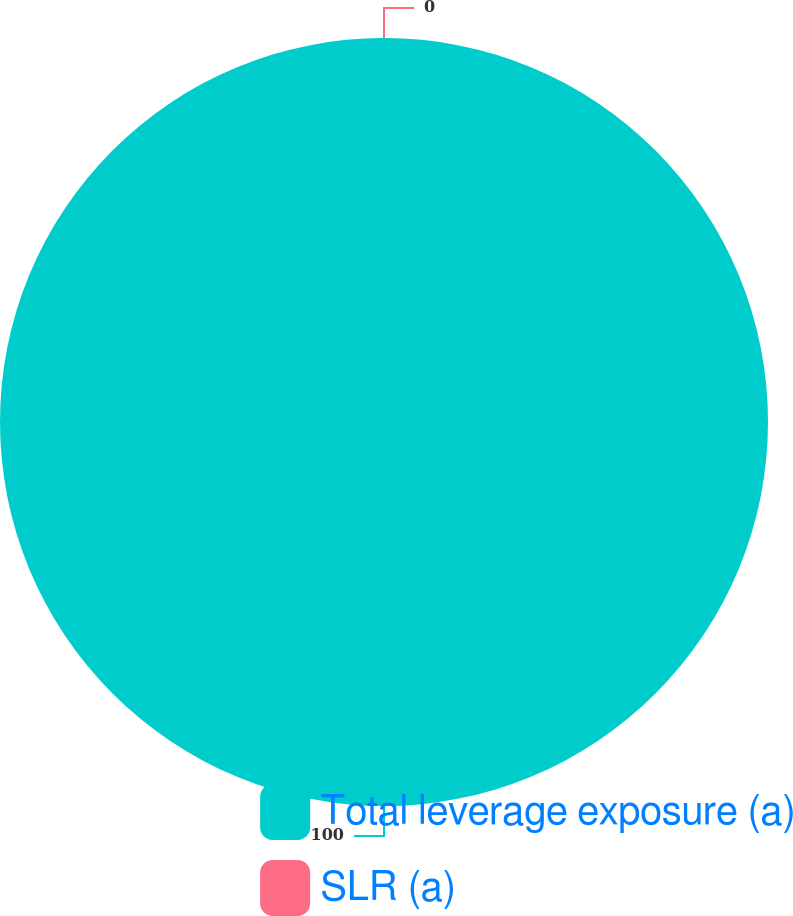<chart> <loc_0><loc_0><loc_500><loc_500><pie_chart><fcel>Total leverage exposure (a)<fcel>SLR (a)<nl><fcel>100.0%<fcel>0.0%<nl></chart> 